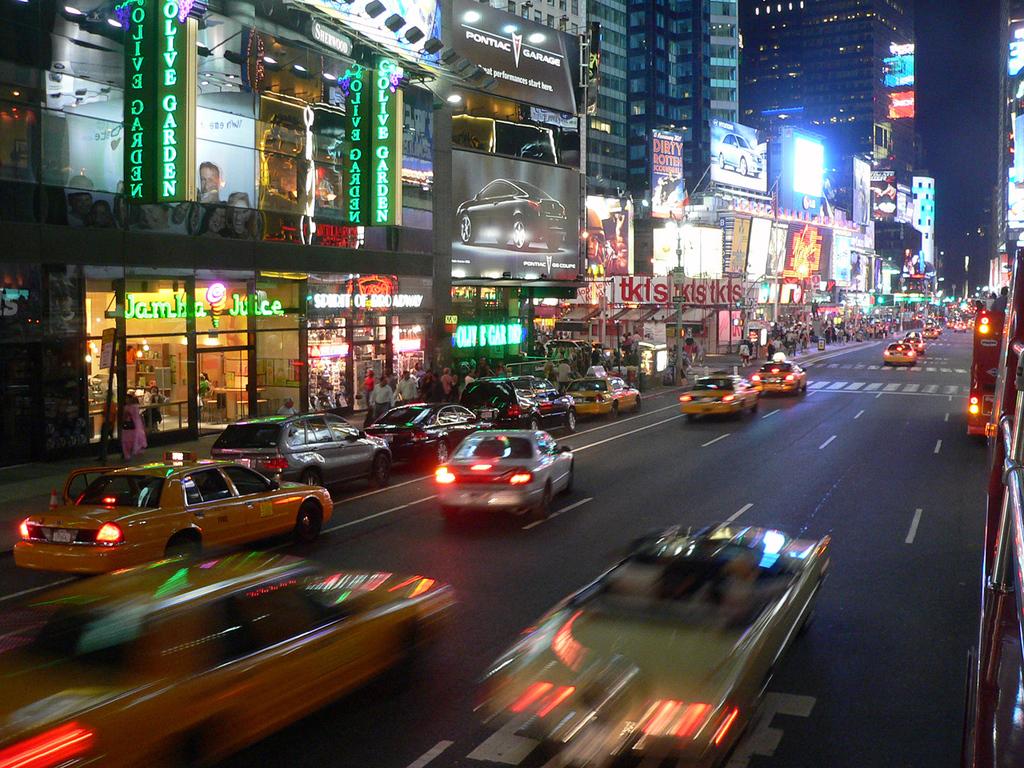What sign is above the jamba juice?
Offer a terse response. Olive garden. What kind of scoundrel is described on the sign?
Offer a terse response. Dirty rotten. 